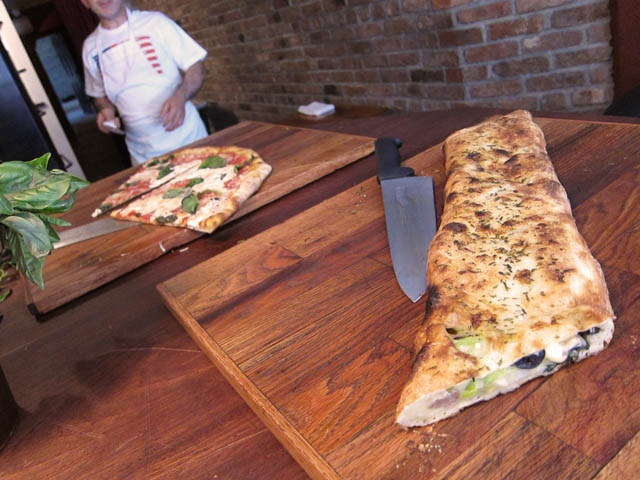Describe the objects in this image and their specific colors. I can see dining table in pink, brown, maroon, and tan tones, pizza in pink, tan, and brown tones, people in pink, lavender, darkgray, and gray tones, pizza in pink, lightgray, and tan tones, and potted plant in pink, darkgreen, black, green, and darkgray tones in this image. 